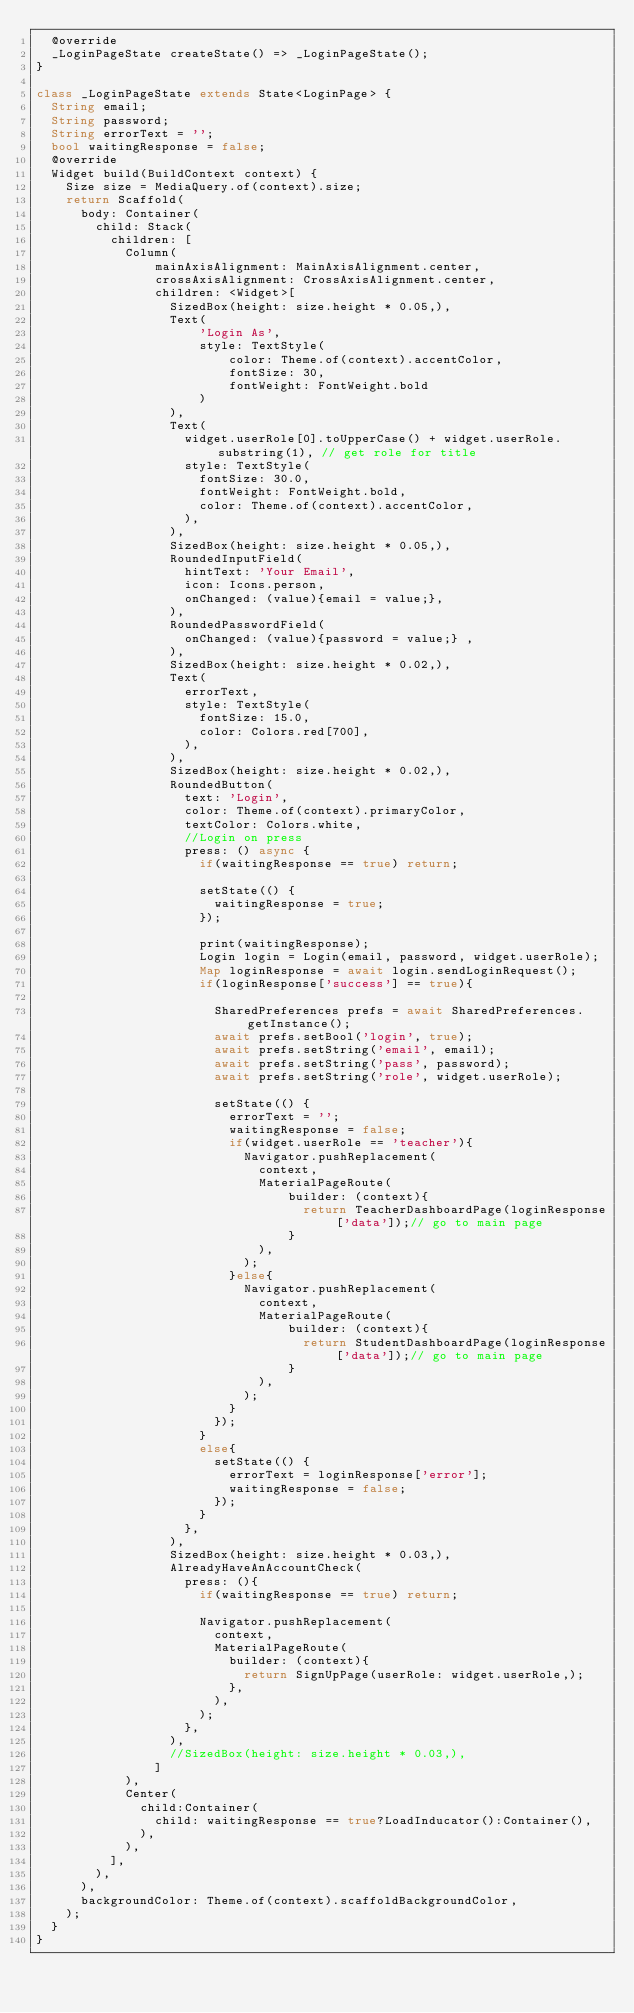<code> <loc_0><loc_0><loc_500><loc_500><_Dart_>  @override
  _LoginPageState createState() => _LoginPageState();
}

class _LoginPageState extends State<LoginPage> {
  String email;
  String password;
  String errorText = '';
  bool waitingResponse = false;
  @override
  Widget build(BuildContext context) {
    Size size = MediaQuery.of(context).size;
    return Scaffold(
      body: Container(
        child: Stack(
          children: [
            Column(
                mainAxisAlignment: MainAxisAlignment.center,
                crossAxisAlignment: CrossAxisAlignment.center,
                children: <Widget>[
                  SizedBox(height: size.height * 0.05,),
                  Text(
                      'Login As',
                      style: TextStyle(
                          color: Theme.of(context).accentColor,
                          fontSize: 30,
                          fontWeight: FontWeight.bold
                      )
                  ),
                  Text(
                    widget.userRole[0].toUpperCase() + widget.userRole.substring(1), // get role for title
                    style: TextStyle(
                      fontSize: 30.0,
                      fontWeight: FontWeight.bold,
                      color: Theme.of(context).accentColor,
                    ),
                  ),
                  SizedBox(height: size.height * 0.05,),
                  RoundedInputField(
                    hintText: 'Your Email',
                    icon: Icons.person,
                    onChanged: (value){email = value;},
                  ),
                  RoundedPasswordField(
                    onChanged: (value){password = value;} ,
                  ),
                  SizedBox(height: size.height * 0.02,),
                  Text(
                    errorText,
                    style: TextStyle(
                      fontSize: 15.0,
                      color: Colors.red[700],
                    ),
                  ),
                  SizedBox(height: size.height * 0.02,),
                  RoundedButton(
                    text: 'Login',
                    color: Theme.of(context).primaryColor,
                    textColor: Colors.white,
                    //Login on press
                    press: () async {
                      if(waitingResponse == true) return;

                      setState(() {
                        waitingResponse = true;
                      });

                      print(waitingResponse);
                      Login login = Login(email, password, widget.userRole);
                      Map loginResponse = await login.sendLoginRequest();
                      if(loginResponse['success'] == true){

                        SharedPreferences prefs = await SharedPreferences.getInstance();
                        await prefs.setBool('login', true);
                        await prefs.setString('email', email);
                        await prefs.setString('pass', password);
                        await prefs.setString('role', widget.userRole);

                        setState(() {
                          errorText = '';
                          waitingResponse = false;
                          if(widget.userRole == 'teacher'){
                            Navigator.pushReplacement(
                              context,
                              MaterialPageRoute(
                                  builder: (context){
                                    return TeacherDashboardPage(loginResponse['data']);// go to main page
                                  }
                              ),
                            );
                          }else{
                            Navigator.pushReplacement(
                              context,
                              MaterialPageRoute(
                                  builder: (context){
                                    return StudentDashboardPage(loginResponse['data']);// go to main page
                                  }
                              ),
                            );
                          }
                        });
                      }
                      else{
                        setState(() {
                          errorText = loginResponse['error'];
                          waitingResponse = false;
                        });
                      }
                    },
                  ),
                  SizedBox(height: size.height * 0.03,),
                  AlreadyHaveAnAccountCheck(
                    press: (){
                      if(waitingResponse == true) return;

                      Navigator.pushReplacement(
                        context,
                        MaterialPageRoute(
                          builder: (context){
                            return SignUpPage(userRole: widget.userRole,);
                          },
                        ),
                      );
                    },
                  ),
                  //SizedBox(height: size.height * 0.03,),
                ]
            ),
            Center(
              child:Container(
                child: waitingResponse == true?LoadInducator():Container(),
              ),
            ),
          ],
        ),
      ),
      backgroundColor: Theme.of(context).scaffoldBackgroundColor,
    );
  }
}</code> 